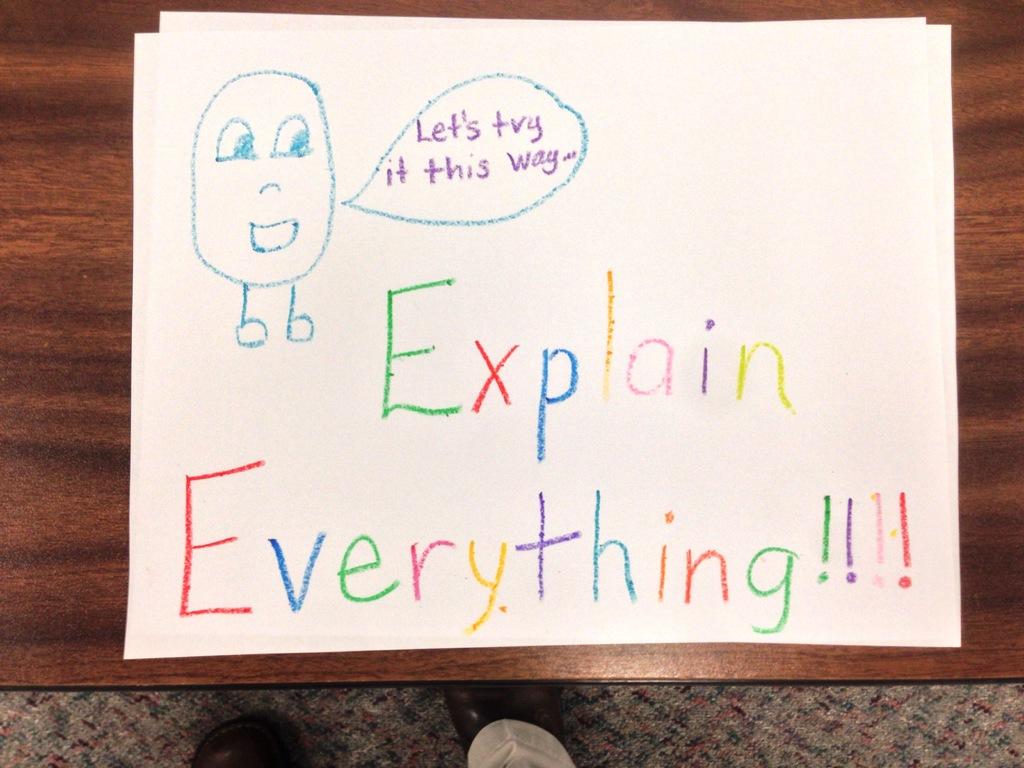What do the colorful letters say?
Ensure brevity in your answer.  Explain everything. What is written in purple with a blue circle around it?
Your response must be concise. Let's try it this way. 